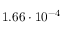<formula> <loc_0><loc_0><loc_500><loc_500>1 . 6 6 \cdot 1 0 ^ { - 4 }</formula> 